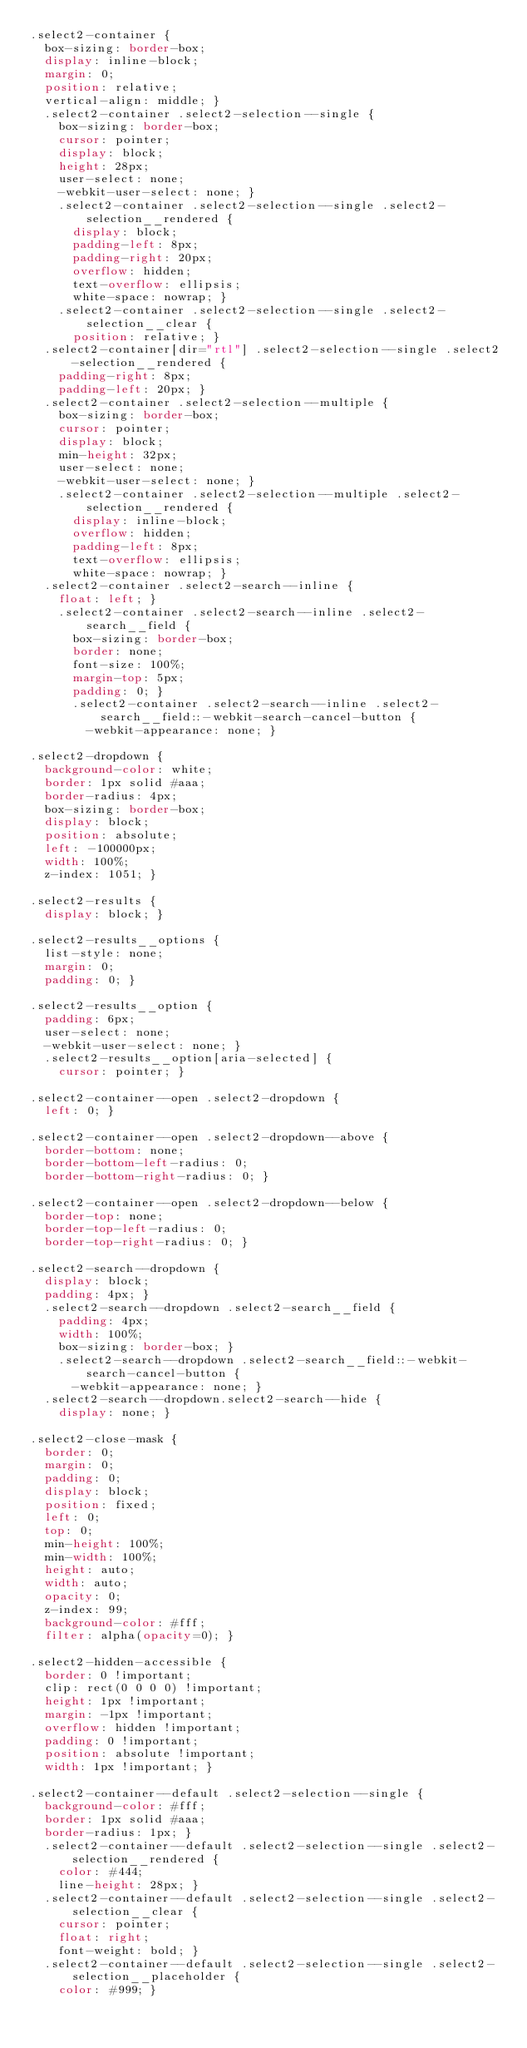Convert code to text. <code><loc_0><loc_0><loc_500><loc_500><_CSS_>.select2-container {
  box-sizing: border-box;
  display: inline-block;
  margin: 0;
  position: relative;
  vertical-align: middle; }
  .select2-container .select2-selection--single {
    box-sizing: border-box;
    cursor: pointer;
    display: block;
    height: 28px;
    user-select: none;
    -webkit-user-select: none; }
    .select2-container .select2-selection--single .select2-selection__rendered {
      display: block;
      padding-left: 8px;
      padding-right: 20px;
      overflow: hidden;
      text-overflow: ellipsis;
      white-space: nowrap; }
    .select2-container .select2-selection--single .select2-selection__clear {
      position: relative; }
  .select2-container[dir="rtl"] .select2-selection--single .select2-selection__rendered {
    padding-right: 8px;
    padding-left: 20px; }
  .select2-container .select2-selection--multiple {
    box-sizing: border-box;
    cursor: pointer;
    display: block;
    min-height: 32px;
    user-select: none;
    -webkit-user-select: none; }
    .select2-container .select2-selection--multiple .select2-selection__rendered {
      display: inline-block;
      overflow: hidden;
      padding-left: 8px;
      text-overflow: ellipsis;
      white-space: nowrap; }
  .select2-container .select2-search--inline {
    float: left; }
    .select2-container .select2-search--inline .select2-search__field {
      box-sizing: border-box;
      border: none;
      font-size: 100%;
      margin-top: 5px;
      padding: 0; }
      .select2-container .select2-search--inline .select2-search__field::-webkit-search-cancel-button {
        -webkit-appearance: none; }

.select2-dropdown {
  background-color: white;
  border: 1px solid #aaa;
  border-radius: 4px;
  box-sizing: border-box;
  display: block;
  position: absolute;
  left: -100000px;
  width: 100%;
  z-index: 1051; }

.select2-results {
  display: block; }

.select2-results__options {
  list-style: none;
  margin: 0;
  padding: 0; }

.select2-results__option {
  padding: 6px;
  user-select: none;
  -webkit-user-select: none; }
  .select2-results__option[aria-selected] {
    cursor: pointer; }

.select2-container--open .select2-dropdown {
  left: 0; }

.select2-container--open .select2-dropdown--above {
  border-bottom: none;
  border-bottom-left-radius: 0;
  border-bottom-right-radius: 0; }

.select2-container--open .select2-dropdown--below {
  border-top: none;
  border-top-left-radius: 0;
  border-top-right-radius: 0; }

.select2-search--dropdown {
  display: block;
  padding: 4px; }
  .select2-search--dropdown .select2-search__field {
    padding: 4px;
    width: 100%;
    box-sizing: border-box; }
    .select2-search--dropdown .select2-search__field::-webkit-search-cancel-button {
      -webkit-appearance: none; }
  .select2-search--dropdown.select2-search--hide {
    display: none; }

.select2-close-mask {
  border: 0;
  margin: 0;
  padding: 0;
  display: block;
  position: fixed;
  left: 0;
  top: 0;
  min-height: 100%;
  min-width: 100%;
  height: auto;
  width: auto;
  opacity: 0;
  z-index: 99;
  background-color: #fff;
  filter: alpha(opacity=0); }

.select2-hidden-accessible {
  border: 0 !important;
  clip: rect(0 0 0 0) !important;
  height: 1px !important;
  margin: -1px !important;
  overflow: hidden !important;
  padding: 0 !important;
  position: absolute !important;
  width: 1px !important; }

.select2-container--default .select2-selection--single {
  background-color: #fff;
  border: 1px solid #aaa;
  border-radius: 1px; }
  .select2-container--default .select2-selection--single .select2-selection__rendered {
    color: #444;
    line-height: 28px; }
  .select2-container--default .select2-selection--single .select2-selection__clear {
    cursor: pointer;
    float: right;
    font-weight: bold; }
  .select2-container--default .select2-selection--single .select2-selection__placeholder {
    color: #999; }</code> 